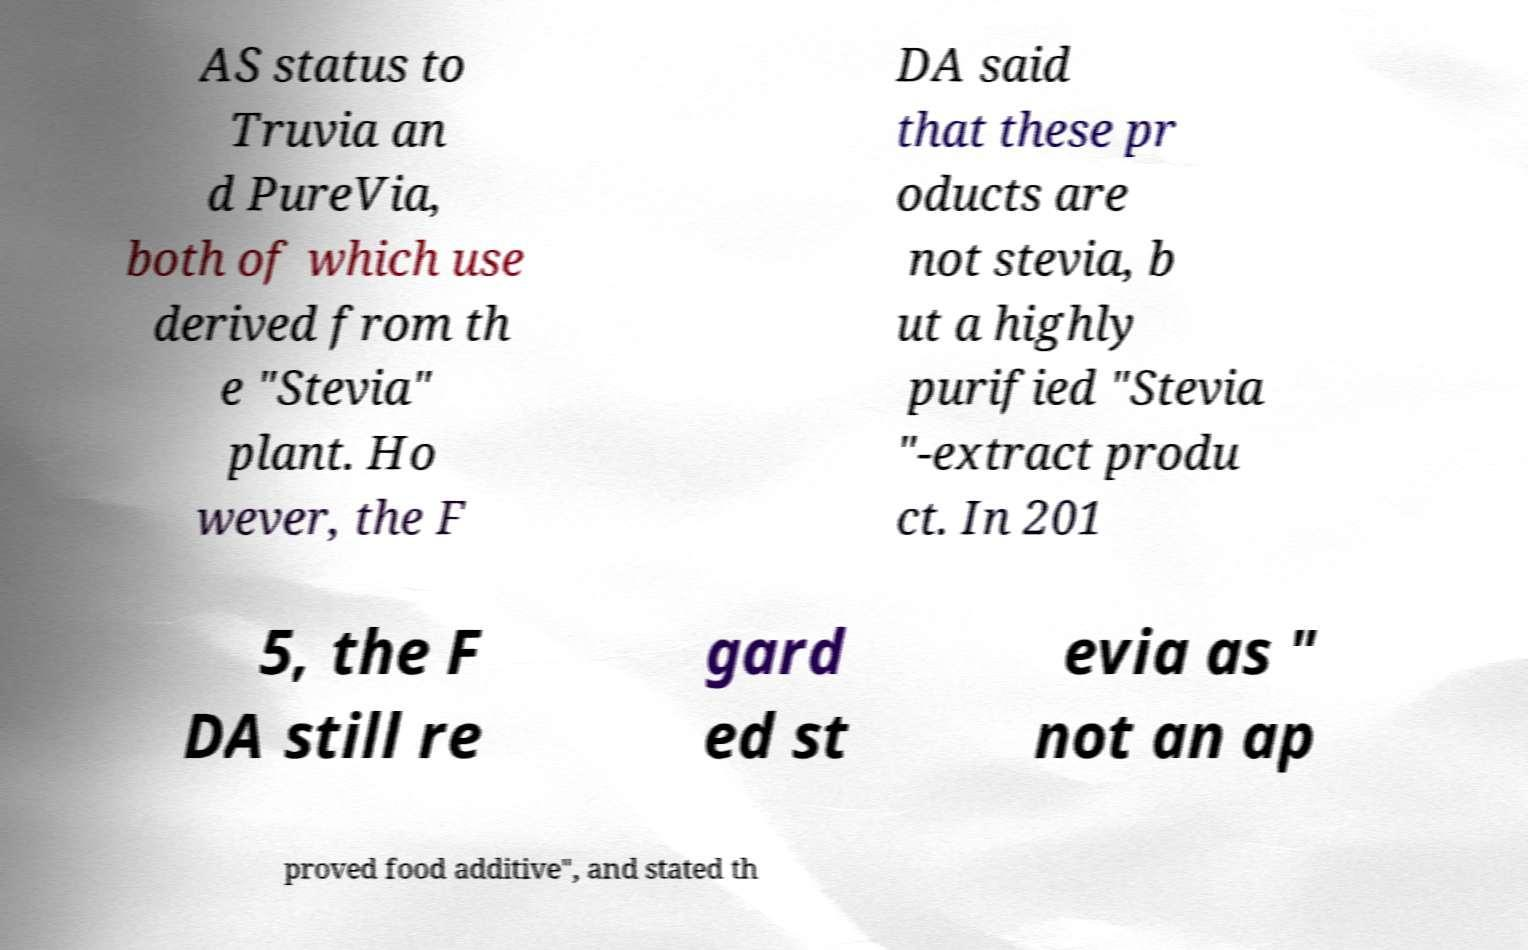Can you read and provide the text displayed in the image?This photo seems to have some interesting text. Can you extract and type it out for me? AS status to Truvia an d PureVia, both of which use derived from th e "Stevia" plant. Ho wever, the F DA said that these pr oducts are not stevia, b ut a highly purified "Stevia "-extract produ ct. In 201 5, the F DA still re gard ed st evia as " not an ap proved food additive", and stated th 